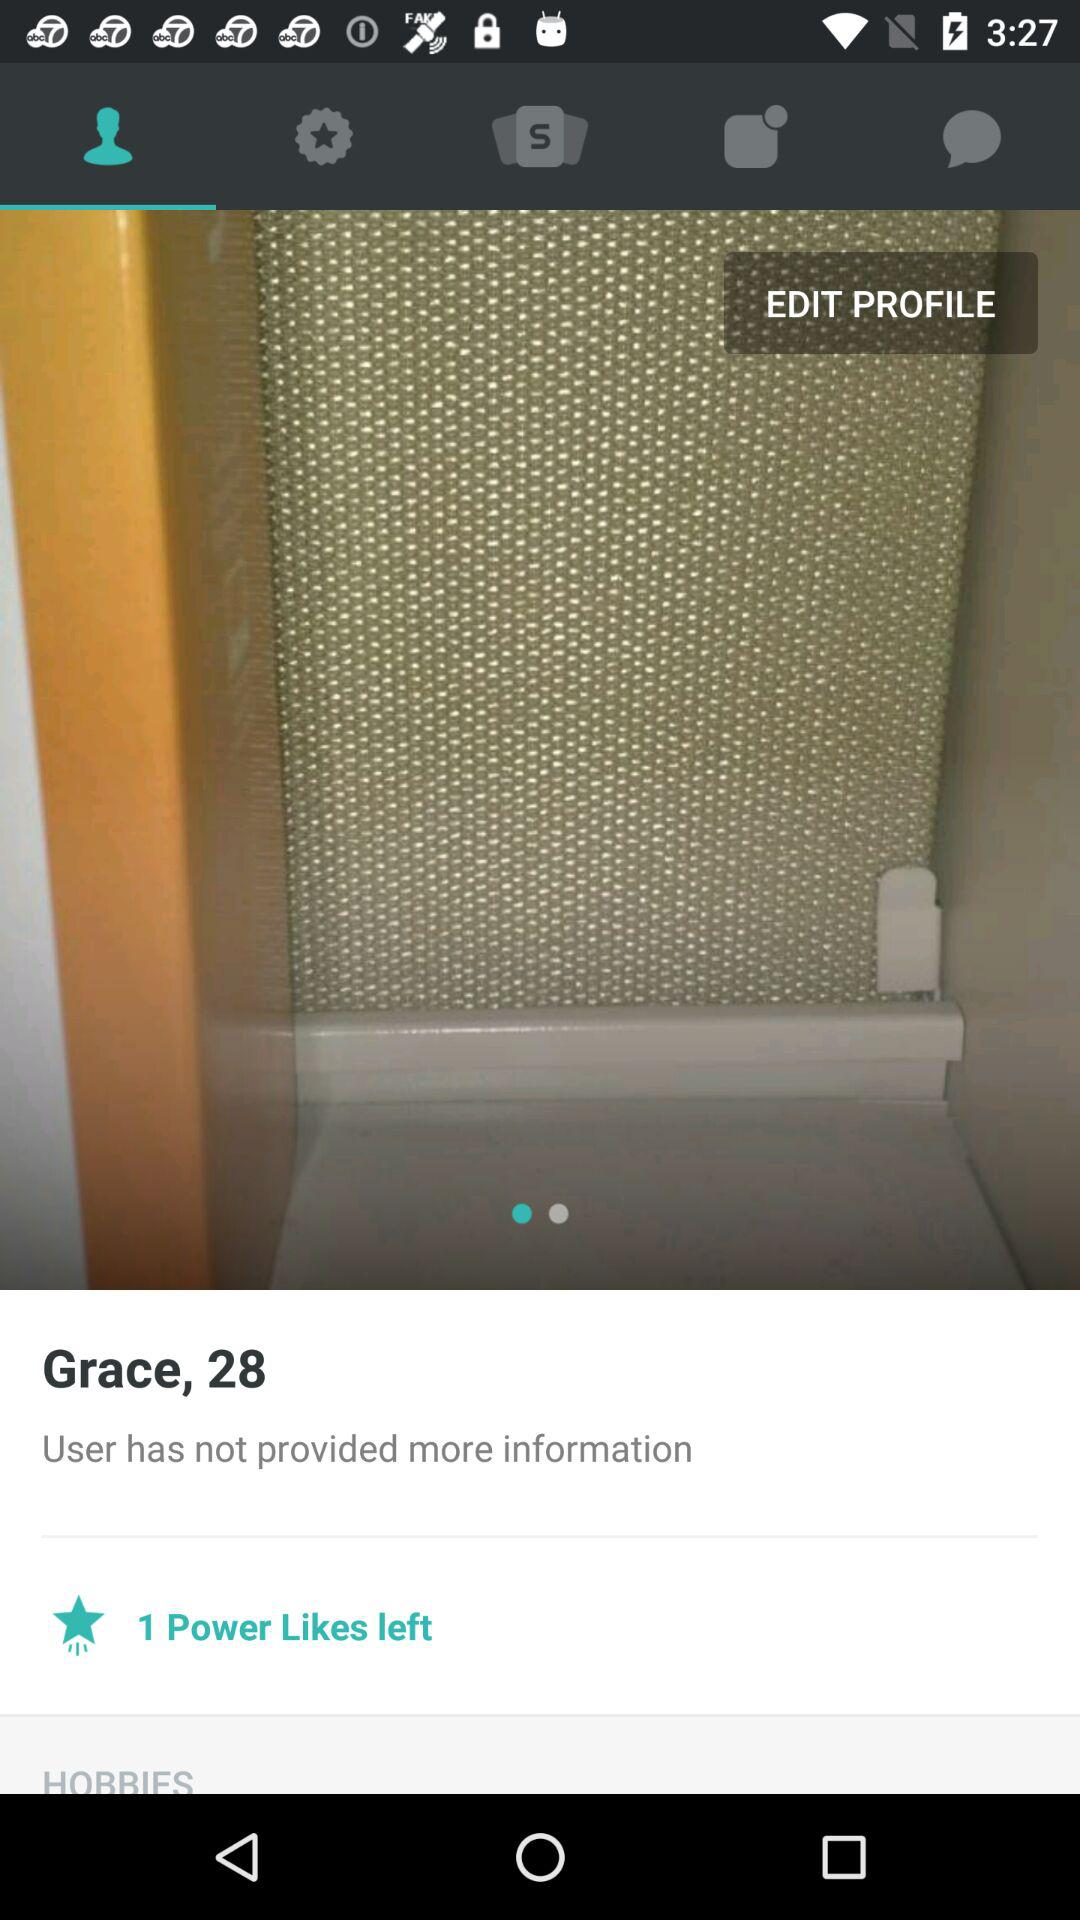What is the age of the user? The age of the user is 28. 